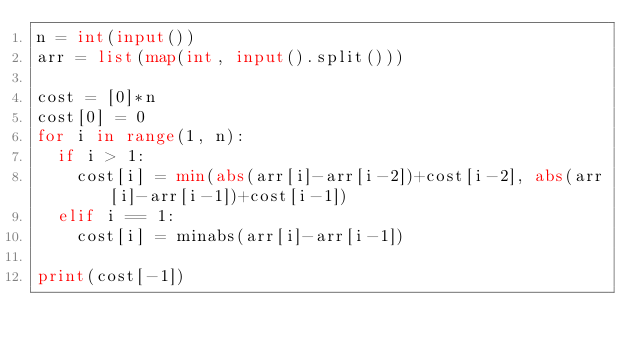<code> <loc_0><loc_0><loc_500><loc_500><_Python_>n = int(input())
arr = list(map(int, input().split()))
  
cost = [0]*n
cost[0] = 0
for i in range(1, n):
  if i > 1:
    cost[i] = min(abs(arr[i]-arr[i-2])+cost[i-2], abs(arr[i]-arr[i-1])+cost[i-1])
  elif i == 1:
    cost[i] = minabs(arr[i]-arr[i-1])

print(cost[-1])</code> 